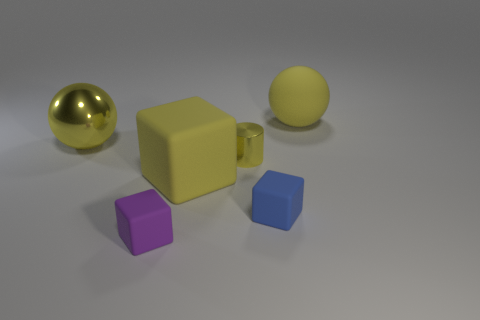What is the material of the small blue object?
Ensure brevity in your answer.  Rubber. There is a tiny yellow cylinder to the right of the tiny purple object; how many big balls are left of it?
Your response must be concise. 1. There is a metal sphere; does it have the same color as the large ball behind the big yellow shiny ball?
Provide a short and direct response. Yes. What color is the rubber sphere that is the same size as the metal sphere?
Provide a succinct answer. Yellow. Is there another big yellow object that has the same shape as the big yellow metallic thing?
Give a very brief answer. Yes. Are there fewer large yellow blocks than brown blocks?
Keep it short and to the point. No. What is the color of the large matte thing left of the tiny yellow thing?
Your response must be concise. Yellow. What shape is the tiny object that is behind the big yellow rubber thing on the left side of the tiny blue matte thing?
Offer a terse response. Cylinder. Is the material of the small purple object the same as the big yellow sphere to the left of the small yellow metal object?
Provide a succinct answer. No. What is the shape of the metal object that is the same color as the metal cylinder?
Keep it short and to the point. Sphere. 